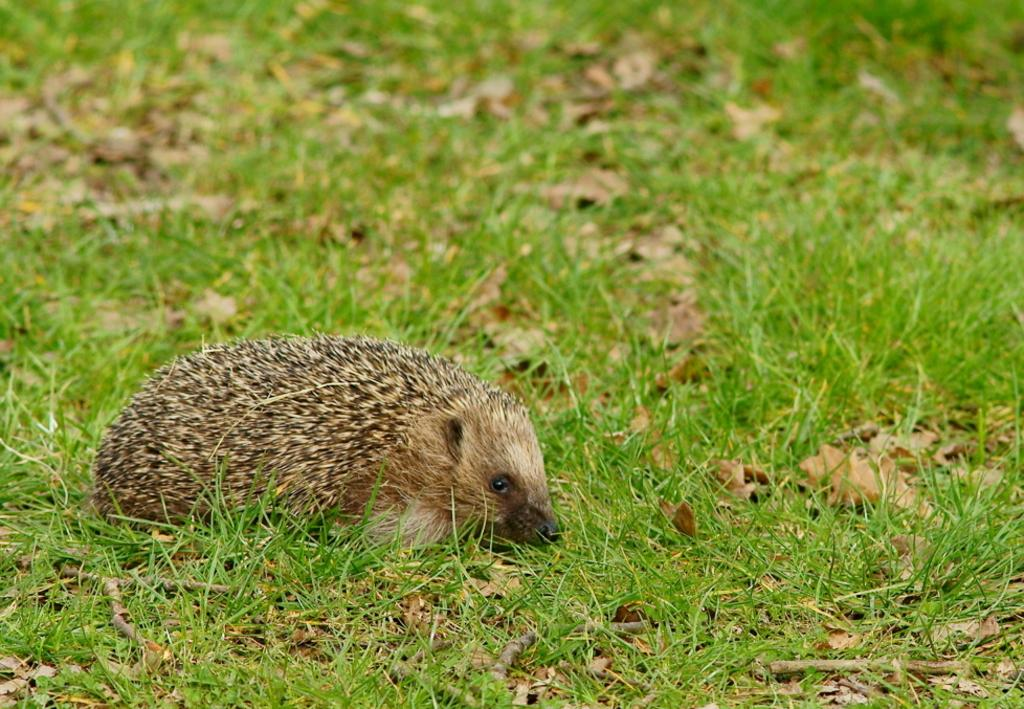What animal is in the picture? There is a Porcupine in the picture. What is on the ground in the picture? There is grass on the ground in the picture. What color are the Porcupine and grass? The color of the Porcupine and grass is brown. How many toes does the Porcupine have in the picture? The number of toes on the Porcupine cannot be determined from the picture, as it is not focused on the feet. 